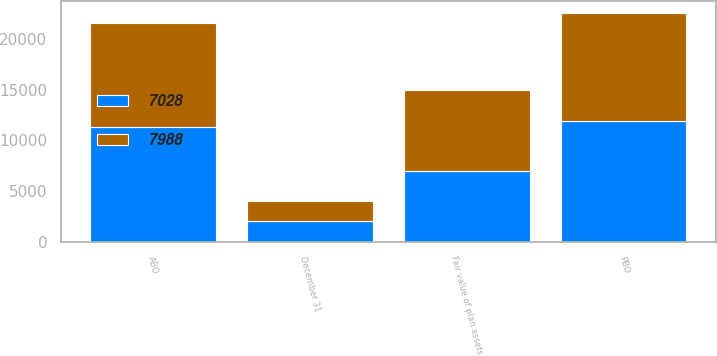<chart> <loc_0><loc_0><loc_500><loc_500><stacked_bar_chart><ecel><fcel>December 31<fcel>PBO<fcel>ABO<fcel>Fair value of plan assets<nl><fcel>7028<fcel>2012<fcel>11956<fcel>11323<fcel>7028<nl><fcel>7988<fcel>2013<fcel>10627<fcel>10275<fcel>7988<nl></chart> 